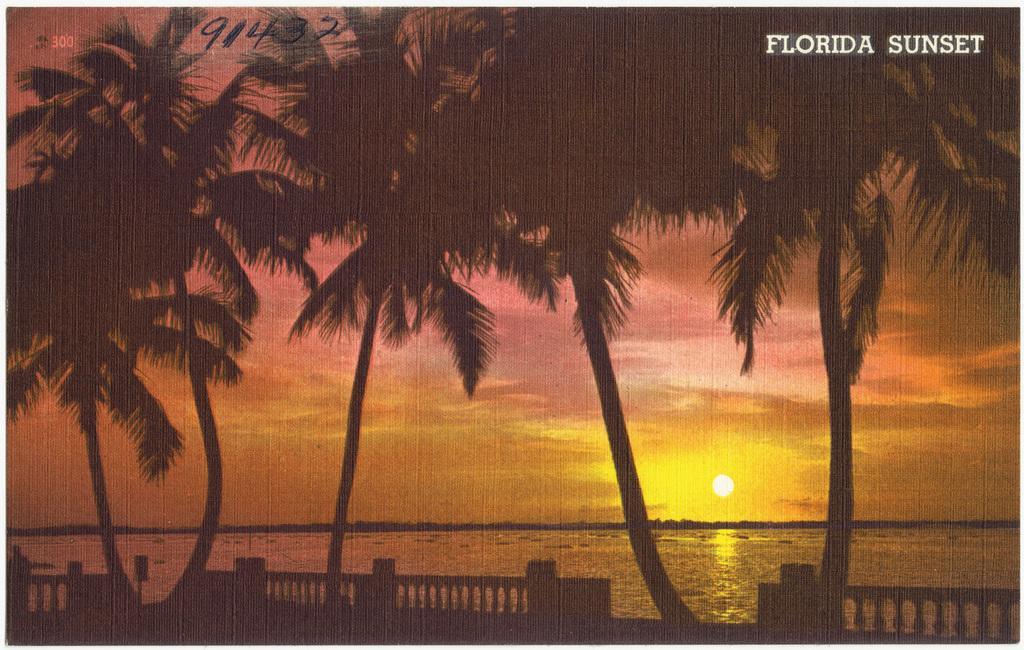Can you describe this image briefly? In the image we can see trees, fence, cloudy sky and the sun. Here we can see the sea and on the top right we can text. 